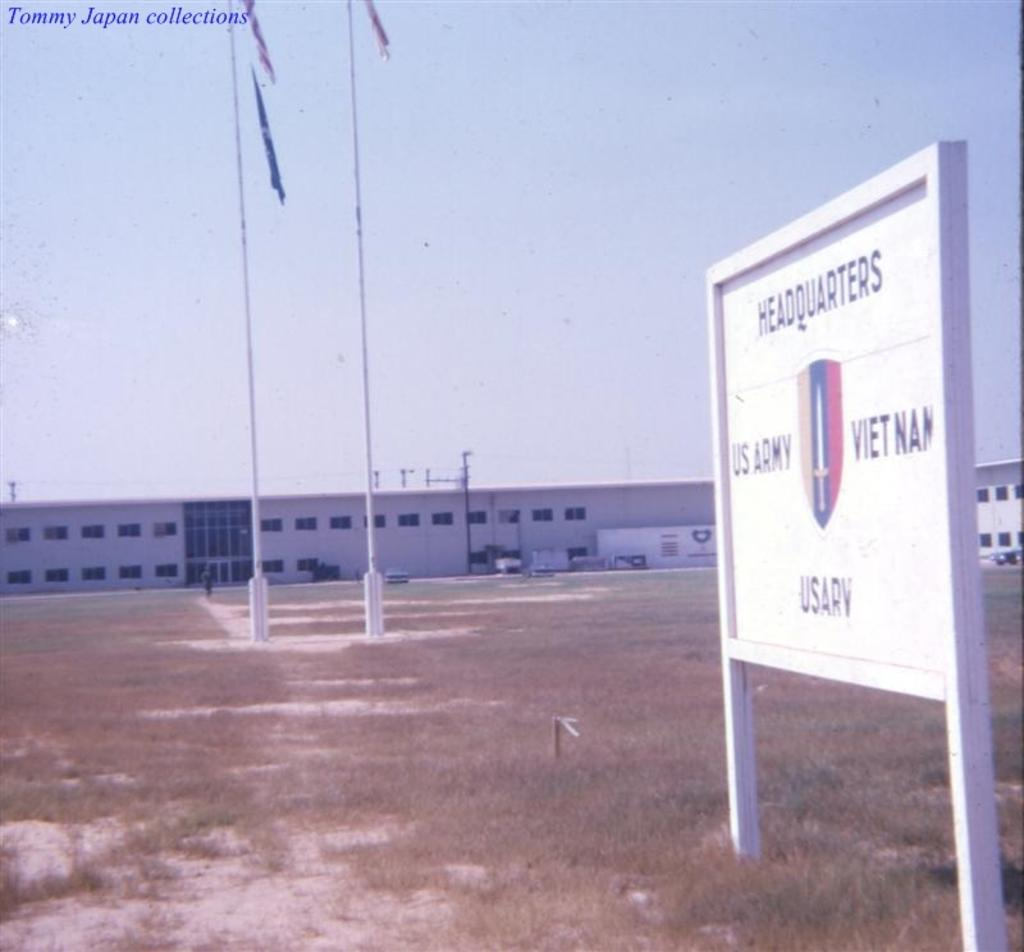<image>
Describe the image concisely. A signboard showing the building is the US Army's Vietnam headquarters. 